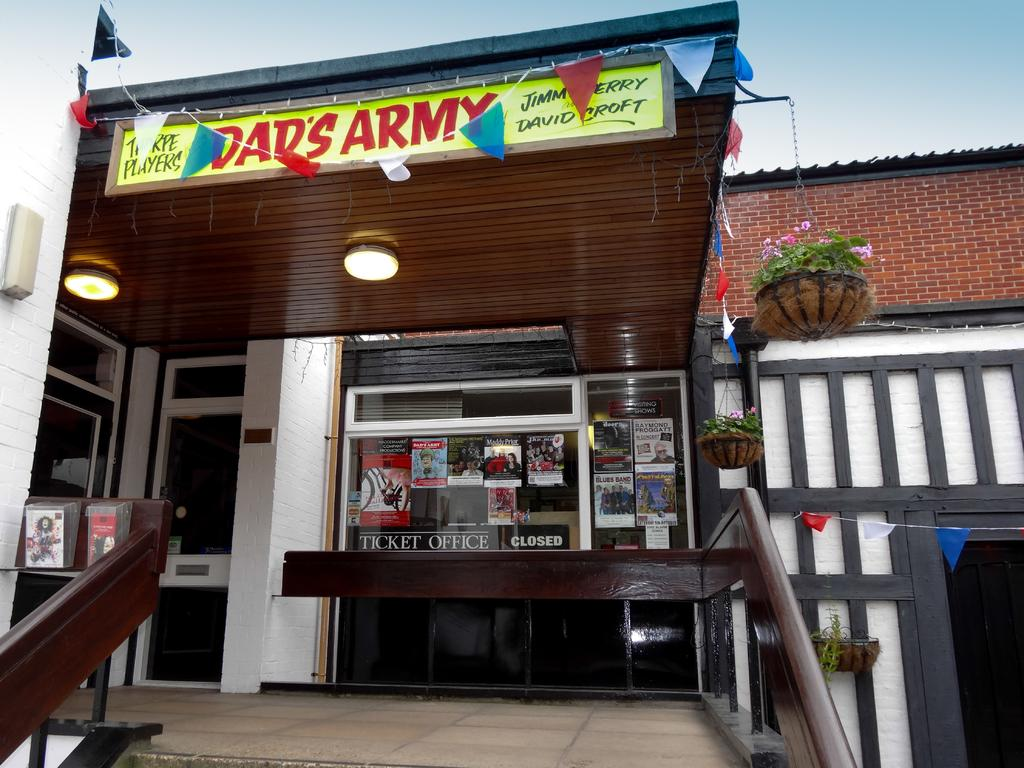<image>
Render a clear and concise summary of the photo. The yellow sign says Dad's Army in red letters. 